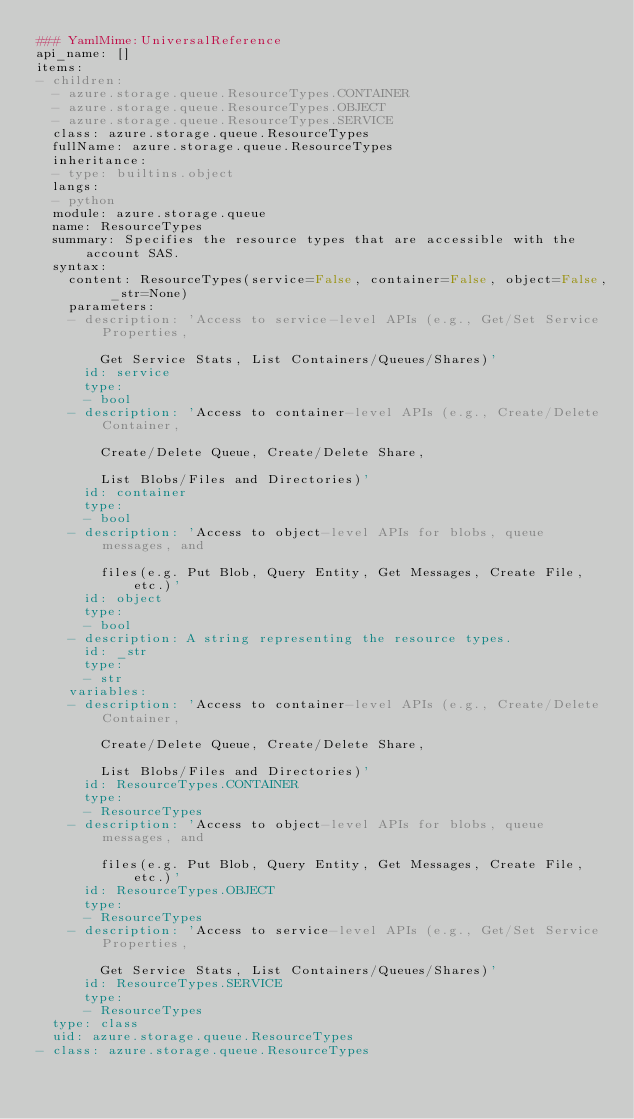<code> <loc_0><loc_0><loc_500><loc_500><_YAML_>### YamlMime:UniversalReference
api_name: []
items:
- children:
  - azure.storage.queue.ResourceTypes.CONTAINER
  - azure.storage.queue.ResourceTypes.OBJECT
  - azure.storage.queue.ResourceTypes.SERVICE
  class: azure.storage.queue.ResourceTypes
  fullName: azure.storage.queue.ResourceTypes
  inheritance:
  - type: builtins.object
  langs:
  - python
  module: azure.storage.queue
  name: ResourceTypes
  summary: Specifies the resource types that are accessible with the account SAS.
  syntax:
    content: ResourceTypes(service=False, container=False, object=False, _str=None)
    parameters:
    - description: 'Access to service-level APIs (e.g., Get/Set Service Properties,

        Get Service Stats, List Containers/Queues/Shares)'
      id: service
      type:
      - bool
    - description: 'Access to container-level APIs (e.g., Create/Delete Container,

        Create/Delete Queue, Create/Delete Share,

        List Blobs/Files and Directories)'
      id: container
      type:
      - bool
    - description: 'Access to object-level APIs for blobs, queue messages, and

        files(e.g. Put Blob, Query Entity, Get Messages, Create File, etc.)'
      id: object
      type:
      - bool
    - description: A string representing the resource types.
      id: _str
      type:
      - str
    variables:
    - description: 'Access to container-level APIs (e.g., Create/Delete Container,

        Create/Delete Queue, Create/Delete Share,

        List Blobs/Files and Directories)'
      id: ResourceTypes.CONTAINER
      type:
      - ResourceTypes
    - description: 'Access to object-level APIs for blobs, queue messages, and

        files(e.g. Put Blob, Query Entity, Get Messages, Create File, etc.)'
      id: ResourceTypes.OBJECT
      type:
      - ResourceTypes
    - description: 'Access to service-level APIs (e.g., Get/Set Service Properties,

        Get Service Stats, List Containers/Queues/Shares)'
      id: ResourceTypes.SERVICE
      type:
      - ResourceTypes
  type: class
  uid: azure.storage.queue.ResourceTypes
- class: azure.storage.queue.ResourceTypes</code> 